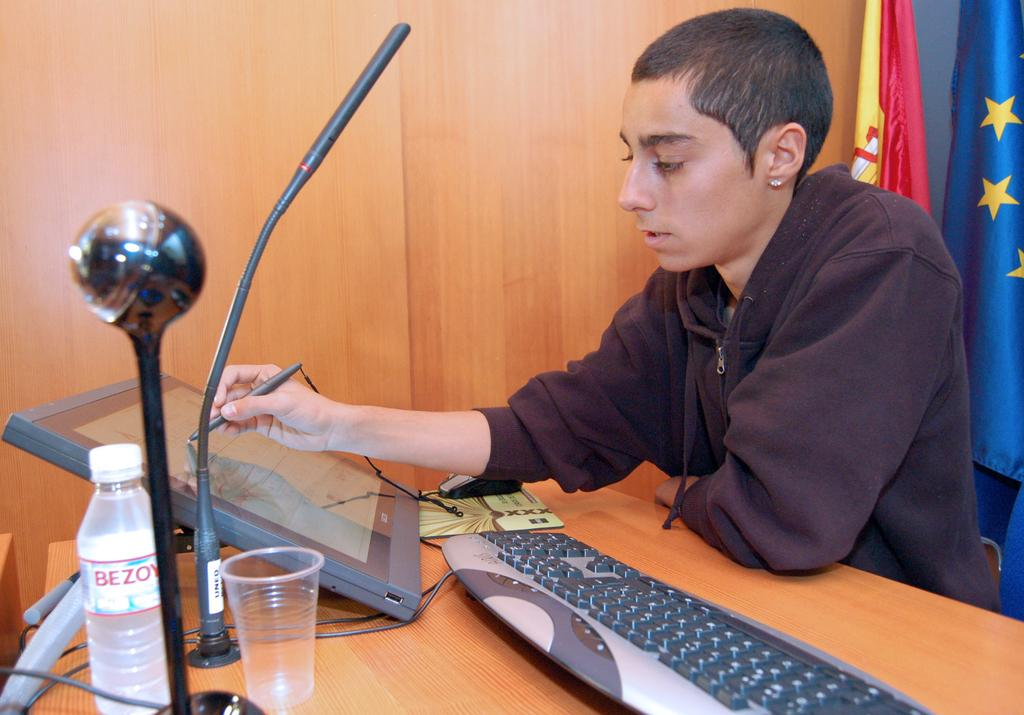<image>
Describe the image concisely. A tan man in a brown sweatshirt drawing on a large tablet and a Bezoy water bottle on the desk. 